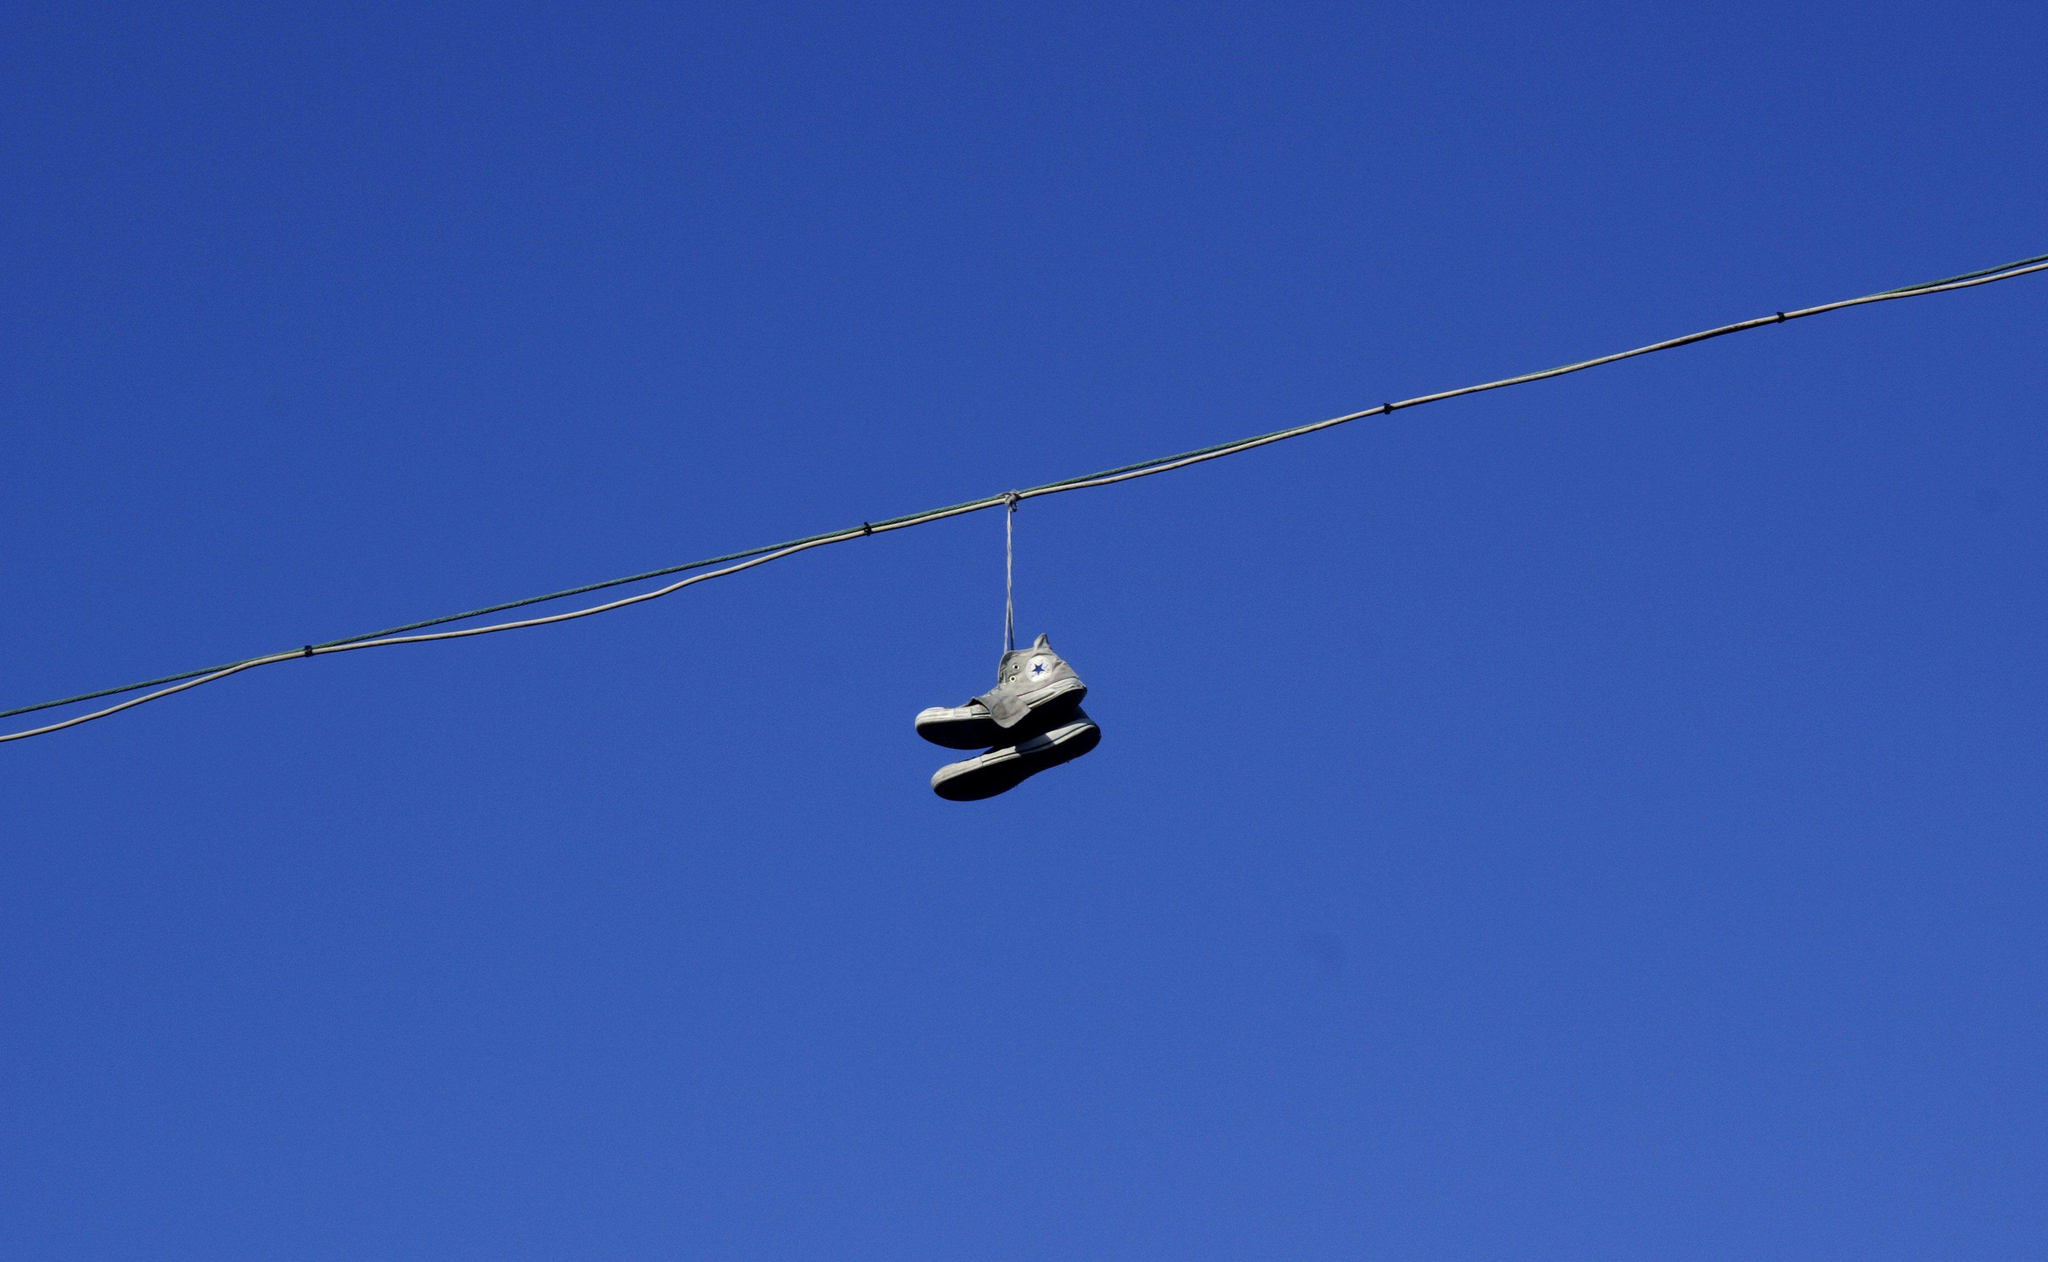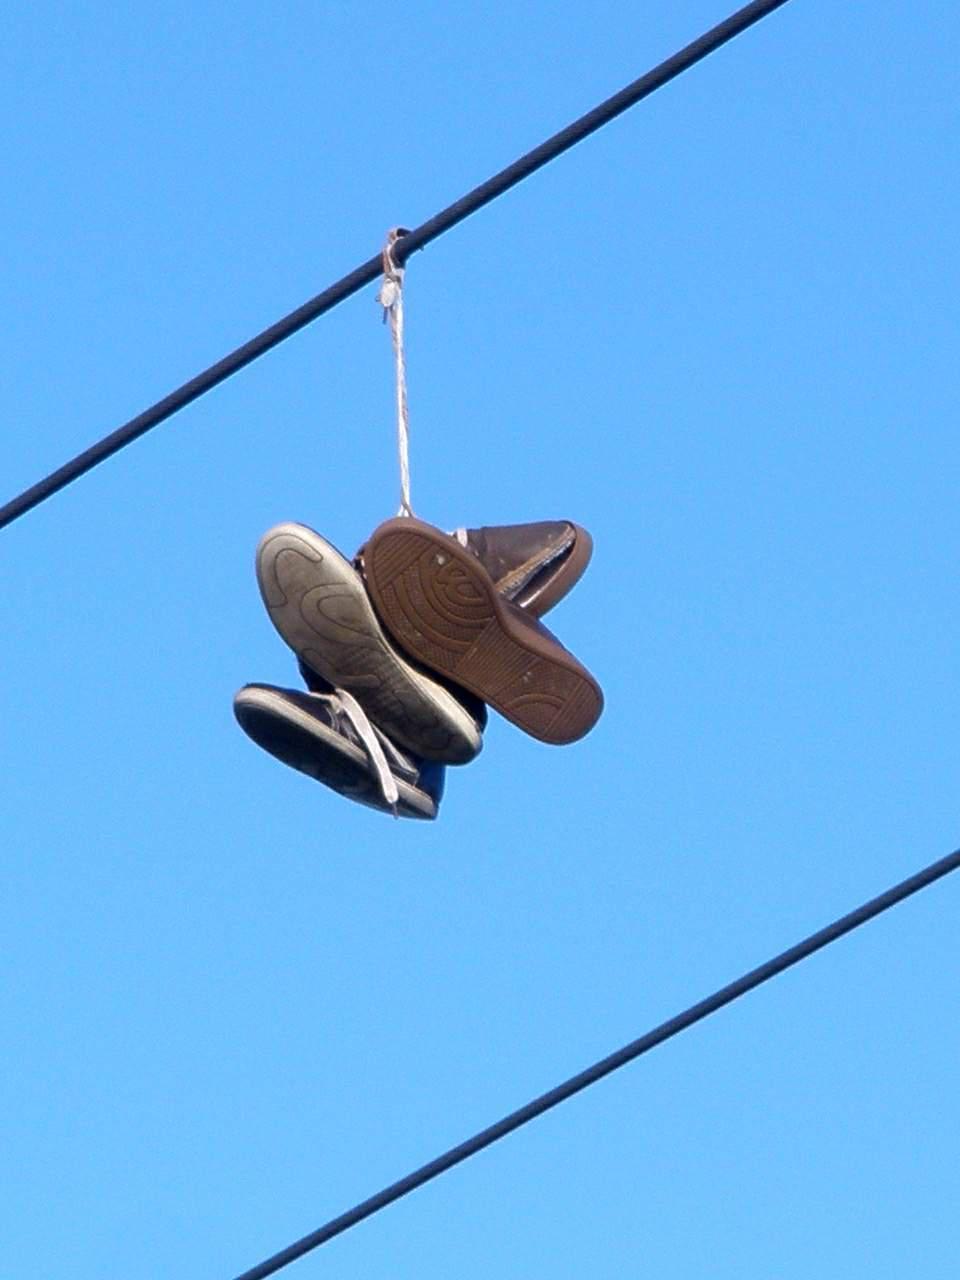The first image is the image on the left, the second image is the image on the right. For the images displayed, is the sentence "One of the images shows multiple pairs of shoes hanging from a power line." factually correct? Answer yes or no. Yes. 